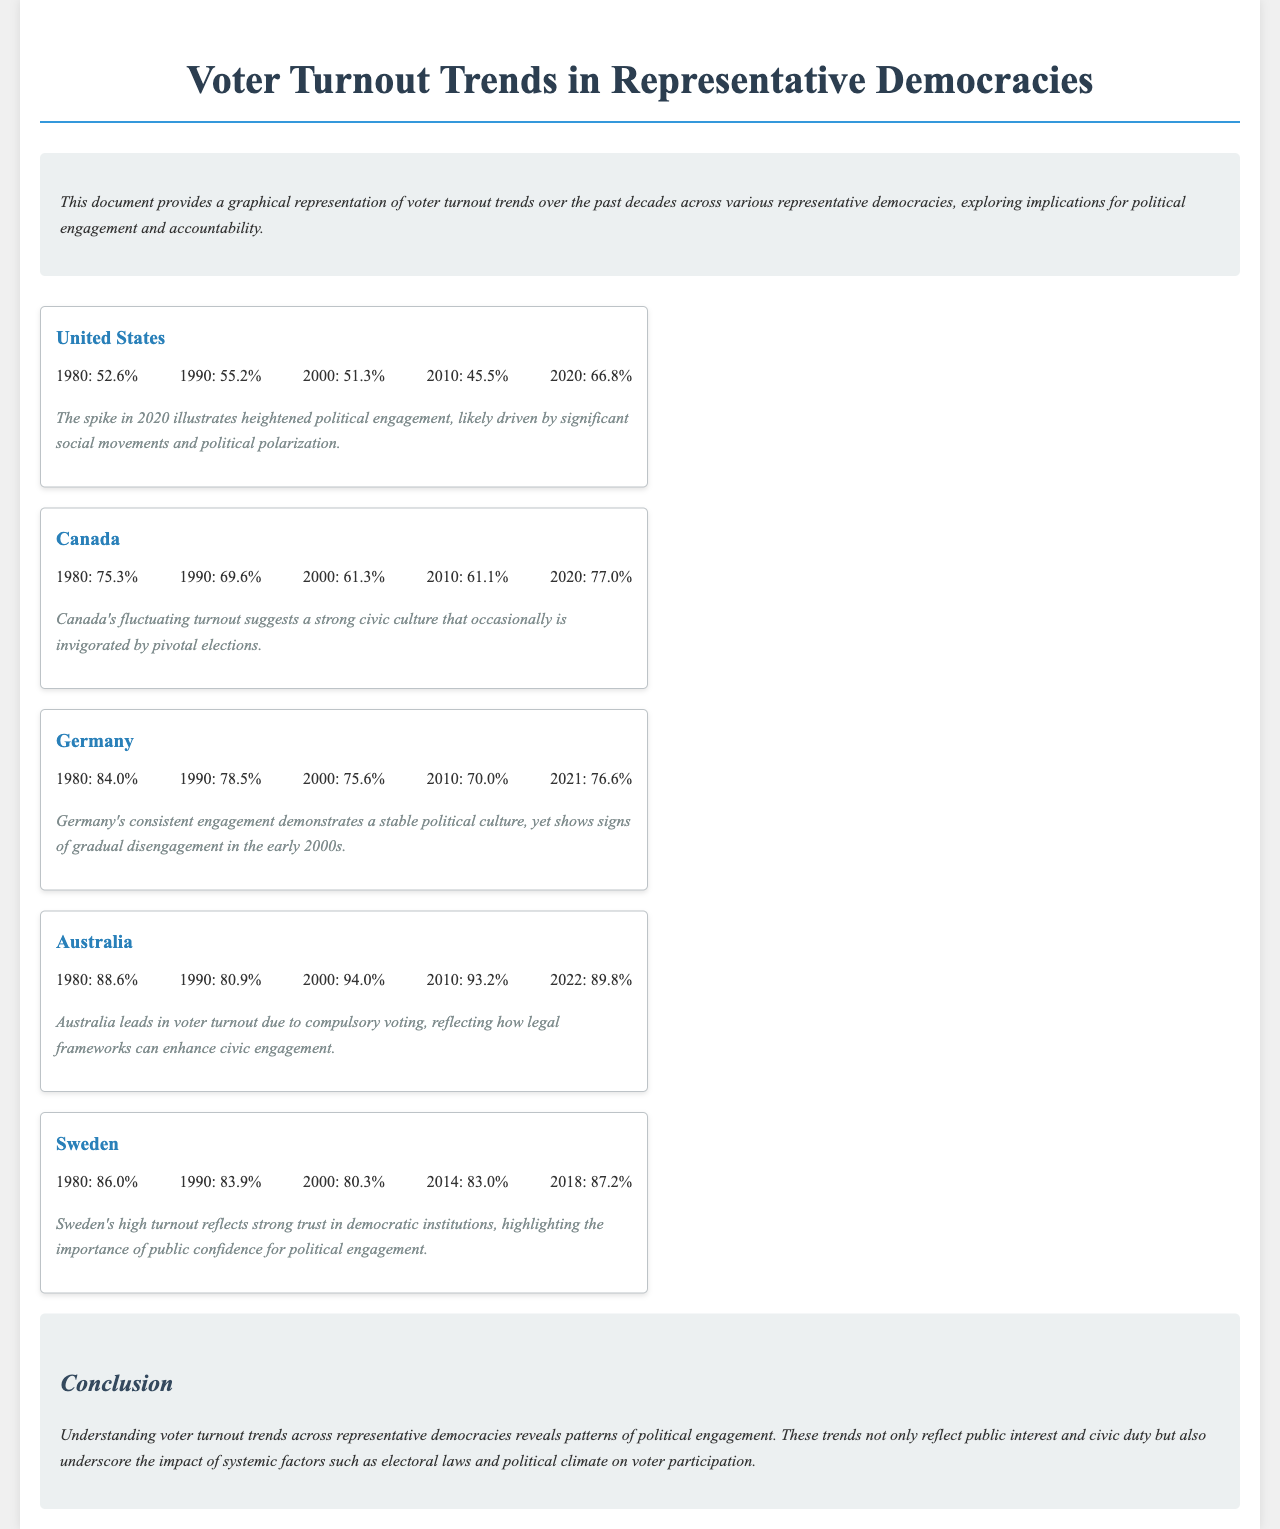What was the voter turnout in the United States in 2020? The voter turnout for the United States in 2020 is listed in the document as 66.8%.
Answer: 66.8% What is the lowest voter turnout recorded for Canada? The lowest voter turnout for Canada, as indicated in the document, is 61.1% in 2010.
Answer: 61.1% Which country had the highest voter turnout in 1980? The document states that Australia had the highest voter turnout in 1980 at 88.6%.
Answer: Australia What are the voter turnout trends for Germany from 1990 to 2021? The trends for Germany indicate a decline from 78.5% in 1990 to 75.6% in 2000, followed by a decrease to 70.0% in 2010, and an increase to 76.6% in 2021.
Answer: 78.5%, 75.6%, 70.0%, 76.6% What implication is suggested by the voter turnout spike in the United States in 2020? The document suggests that the spike in 2020 illustrates heightened political engagement, likely driven by significant social movements and political polarization.
Answer: Heightened political engagement Which country leads in voter turnout due to compulsory voting? The document indicates that Australia leads in voter turnout due to compulsory voting.
Answer: Australia What percentage of voters turned out in Sweden in 2018? The document states that the voter turnout in Sweden in 2018 was 87.2%.
Answer: 87.2% What conclusion can be drawn about the impact of legal frameworks on voter turnout? The conclusion drawn from the document is that legal frameworks, such as compulsory voting, can enhance civic engagement.
Answer: Enhance civic engagement 